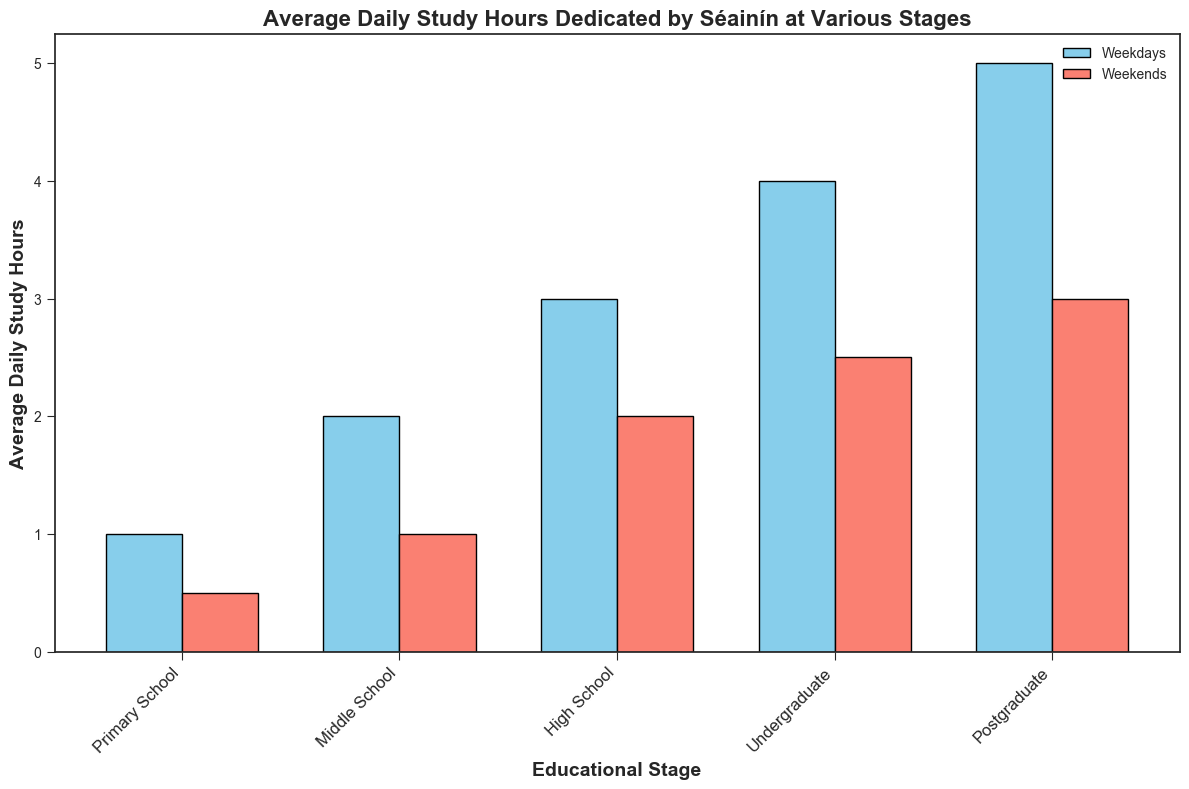What is the difference in study hours between weekdays and weekends during primary school? The bar for weekdays during primary school shows an average of 1 hour, while the bar for weekends shows 0.5 hours. The difference is calculated as 1 - 0.5.
Answer: 0.5 hours In which educational stage does Séainín study the most on weekends? The tallest bar in the weekends category corresponds to the "Postgraduate" stage with an average of 3 hours.
Answer: Postgraduate How much more does Séainín study on weekdays compared to weekends at the postgraduate level? The bar for weekdays in the postgraduate stage shows an average of 5 hours, while the bar for weekends shows 3 hours. The difference is 5 - 3.
Answer: 2 hours Which educational stage has the smallest difference in study hours between weekdays and weekends? The differences between weekday and weekend study hours for each stage are: Primary School (0.5), Middle School (1), High School (1), Undergraduate (1.5), Postgraduate (2). The smallest difference is 0.5 for Primary School.
Answer: Primary School What is the total number of study hours on an average day (combining weekdays and weekends) in middle school? On weekdays, Séainín studies 2 hours, and on weekends, it is 1 hour. To find the average: (2 + 1) / 2 = 1.5 hours per day.
Answer: 1.5 hours per day Between which two educational stages is there the largest increase in average weekday study hours? The increases between stages are: Primary to Middle (1 hour), Middle to High (1 hour), High to Undergraduate (1 hour), Undergraduate to Postgraduate (1 hour). Each increment is equal, calculated as 1 hour.
Answer: Primary to Middle, Middle to High, High to Undergraduate, Undergraduate to Postgraduate What is the average study time on weekdays across all stages? The average is obtained by summing all weekday amounts and dividing by the number of stages: (1 + 2 + 3 + 4 + 5) / 5 = 3 hours.
Answer: 3 hours Comparing high school and undergraduate stages, how many more hours does Séainín study on weekends in the undergraduate stage? The bar for high school weekends shows 2 hours, while the undergraduate weekends show 2.5 hours. The difference is 2.5 - 2.
Answer: 0.5 hours 